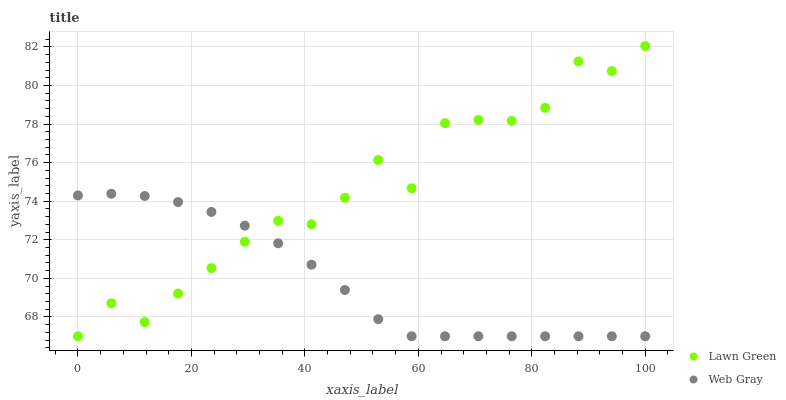Does Web Gray have the minimum area under the curve?
Answer yes or no. Yes. Does Lawn Green have the maximum area under the curve?
Answer yes or no. Yes. Does Web Gray have the maximum area under the curve?
Answer yes or no. No. Is Web Gray the smoothest?
Answer yes or no. Yes. Is Lawn Green the roughest?
Answer yes or no. Yes. Is Web Gray the roughest?
Answer yes or no. No. Does Lawn Green have the lowest value?
Answer yes or no. Yes. Does Lawn Green have the highest value?
Answer yes or no. Yes. Does Web Gray have the highest value?
Answer yes or no. No. Does Web Gray intersect Lawn Green?
Answer yes or no. Yes. Is Web Gray less than Lawn Green?
Answer yes or no. No. Is Web Gray greater than Lawn Green?
Answer yes or no. No. 